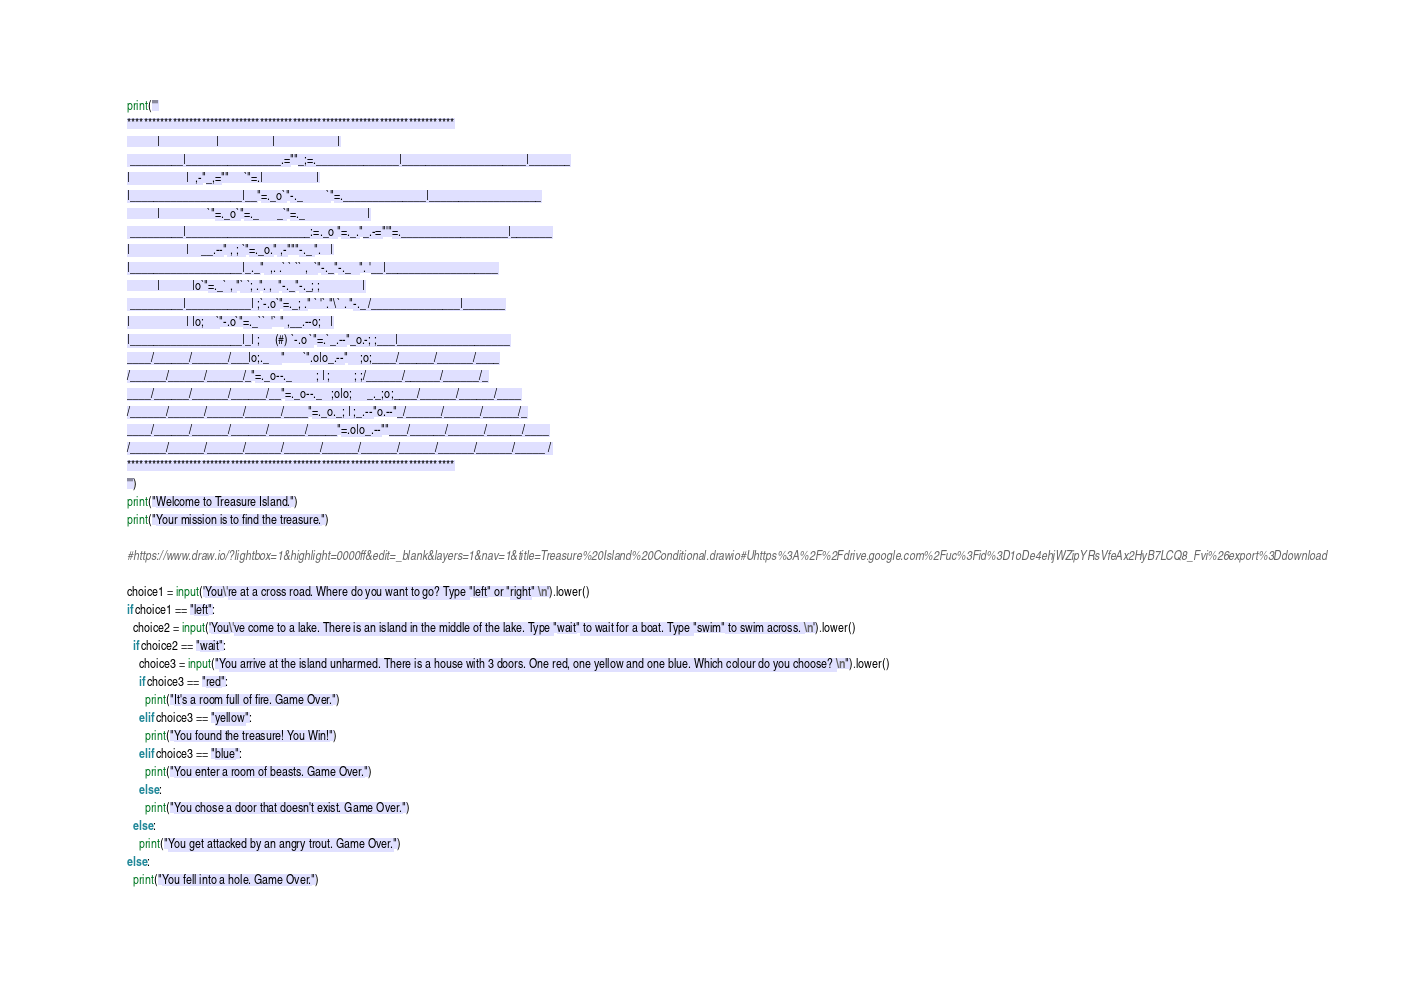Convert code to text. <code><loc_0><loc_0><loc_500><loc_500><_Python_>print('''
*******************************************************************************
          |                   |                  |                     |
 _________|________________.=""_;=.______________|_____________________|_______
|                   |  ,-"_,=""     `"=.|                  |
|___________________|__"=._o`"-._        `"=.______________|___________________
          |                `"=._o`"=._      _`"=._                     |
 _________|_____________________:=._o "=._."_.-="'"=.__________________|_______
|                   |    __.--" , ; `"=._o." ,-"""-._ ".   |
|___________________|_._"  ,. .` ` `` ,  `"-._"-._   ". '__|___________________
          |           |o`"=._` , "` `; .". ,  "-._"-._; ;              |
 _________|___________| ;`-.o`"=._; ." ` '`."\` . "-._ /_______________|_______
|                   | |o;    `"-.o`"=._``  '` " ,__.--o;   |
|___________________|_| ;     (#) `-.o `"=.`_.--"_o.-; ;___|___________________
____/______/______/___|o;._    "      `".o|o_.--"    ;o;____/______/______/____
/______/______/______/_"=._o--._        ; | ;        ; ;/______/______/______/_
____/______/______/______/__"=._o--._   ;o|o;     _._;o;____/______/______/____
/______/______/______/______/____"=._o._; | ;_.--"o.--"_/______/______/______/_
____/______/______/______/______/_____"=.o|o_.--""___/______/______/______/____
/______/______/______/______/______/______/______/______/______/______/_____ /
*******************************************************************************
''')
print("Welcome to Treasure Island.")
print("Your mission is to find the treasure.") 

#https://www.draw.io/?lightbox=1&highlight=0000ff&edit=_blank&layers=1&nav=1&title=Treasure%20Island%20Conditional.drawio#Uhttps%3A%2F%2Fdrive.google.com%2Fuc%3Fid%3D1oDe4ehjWZipYRsVfeAx2HyB7LCQ8_Fvi%26export%3Ddownload

choice1 = input('You\'re at a cross road. Where do you want to go? Type "left" or "right" \n').lower()
if choice1 == "left":
  choice2 = input('You\'ve come to a lake. There is an island in the middle of the lake. Type "wait" to wait for a boat. Type "swim" to swim across. \n').lower()
  if choice2 == "wait":
    choice3 = input("You arrive at the island unharmed. There is a house with 3 doors. One red, one yellow and one blue. Which colour do you choose? \n").lower()
    if choice3 == "red":
      print("It's a room full of fire. Game Over.")
    elif choice3 == "yellow":
      print("You found the treasure! You Win!")
    elif choice3 == "blue":
      print("You enter a room of beasts. Game Over.")
    else:
      print("You chose a door that doesn't exist. Game Over.")
  else:
    print("You get attacked by an angry trout. Game Over.")
else:
  print("You fell into a hole. Game Over.")</code> 